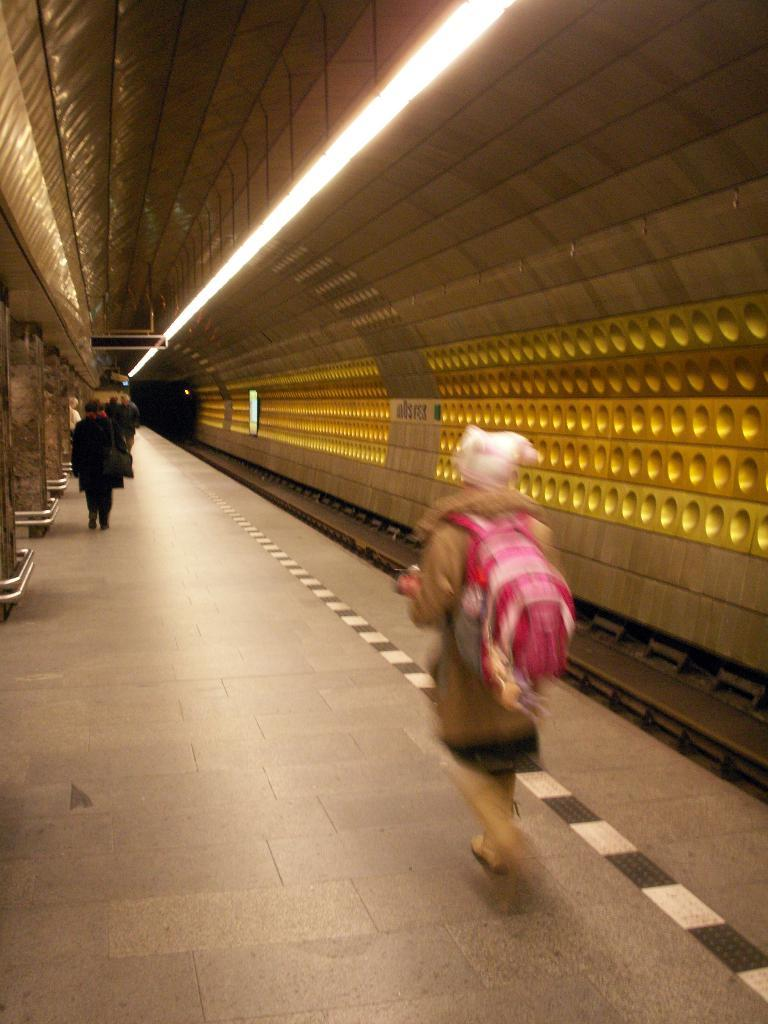Who or what can be seen in the image? There are people in the image. What structure is present in the image? There is a platform and pillars in the image. What is the source of illumination in the image? There is light in the image. What is covering the top of the structure in the image? There is a roof in the image. What type of operation is being performed on the people in the image? There is no operation being performed on the people in the image. Can you see a flame in the image? There is no flame present in the image. 